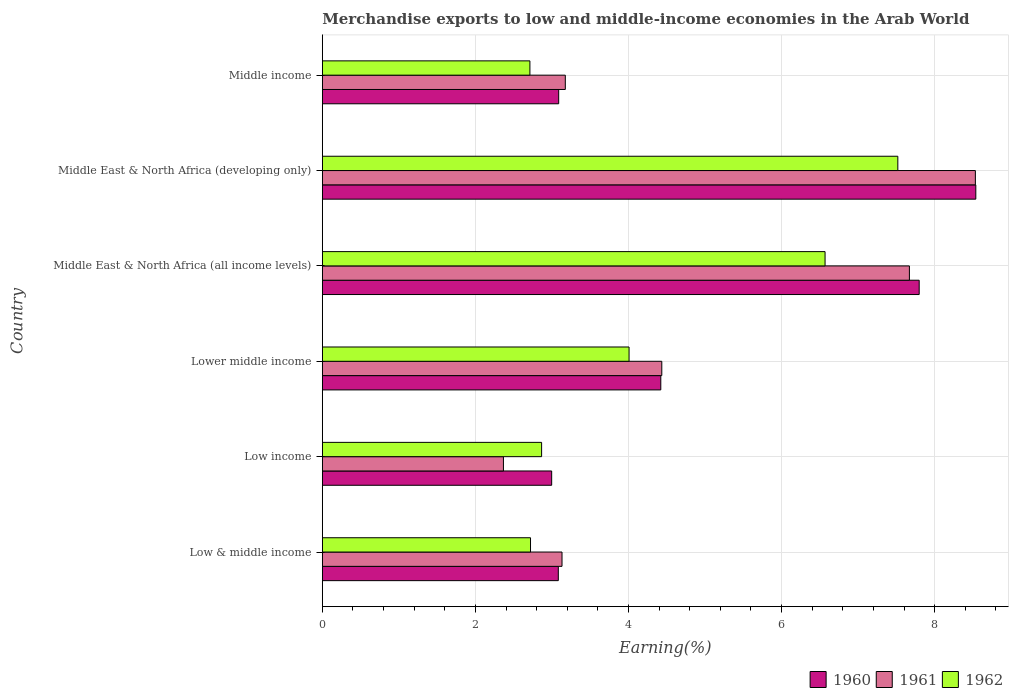How many different coloured bars are there?
Make the answer very short. 3. What is the label of the 2nd group of bars from the top?
Make the answer very short. Middle East & North Africa (developing only). What is the percentage of amount earned from merchandise exports in 1962 in Lower middle income?
Offer a terse response. 4.01. Across all countries, what is the maximum percentage of amount earned from merchandise exports in 1961?
Keep it short and to the point. 8.53. Across all countries, what is the minimum percentage of amount earned from merchandise exports in 1962?
Provide a succinct answer. 2.71. In which country was the percentage of amount earned from merchandise exports in 1961 maximum?
Make the answer very short. Middle East & North Africa (developing only). In which country was the percentage of amount earned from merchandise exports in 1962 minimum?
Provide a succinct answer. Middle income. What is the total percentage of amount earned from merchandise exports in 1960 in the graph?
Your answer should be compact. 29.92. What is the difference between the percentage of amount earned from merchandise exports in 1960 in Lower middle income and that in Middle East & North Africa (developing only)?
Keep it short and to the point. -4.12. What is the difference between the percentage of amount earned from merchandise exports in 1962 in Middle East & North Africa (developing only) and the percentage of amount earned from merchandise exports in 1961 in Middle East & North Africa (all income levels)?
Give a very brief answer. -0.15. What is the average percentage of amount earned from merchandise exports in 1962 per country?
Offer a very short reply. 4.4. What is the difference between the percentage of amount earned from merchandise exports in 1962 and percentage of amount earned from merchandise exports in 1961 in Middle East & North Africa (all income levels)?
Your answer should be compact. -1.1. In how many countries, is the percentage of amount earned from merchandise exports in 1960 greater than 2 %?
Your answer should be very brief. 6. What is the ratio of the percentage of amount earned from merchandise exports in 1962 in Low income to that in Middle East & North Africa (developing only)?
Provide a short and direct response. 0.38. Is the difference between the percentage of amount earned from merchandise exports in 1962 in Low & middle income and Middle East & North Africa (all income levels) greater than the difference between the percentage of amount earned from merchandise exports in 1961 in Low & middle income and Middle East & North Africa (all income levels)?
Keep it short and to the point. Yes. What is the difference between the highest and the second highest percentage of amount earned from merchandise exports in 1960?
Your answer should be compact. 0.74. What is the difference between the highest and the lowest percentage of amount earned from merchandise exports in 1962?
Give a very brief answer. 4.81. Is it the case that in every country, the sum of the percentage of amount earned from merchandise exports in 1960 and percentage of amount earned from merchandise exports in 1962 is greater than the percentage of amount earned from merchandise exports in 1961?
Your response must be concise. Yes. How many bars are there?
Provide a succinct answer. 18. Are the values on the major ticks of X-axis written in scientific E-notation?
Keep it short and to the point. No. Does the graph contain grids?
Keep it short and to the point. Yes. Where does the legend appear in the graph?
Offer a very short reply. Bottom right. How are the legend labels stacked?
Your answer should be very brief. Horizontal. What is the title of the graph?
Provide a succinct answer. Merchandise exports to low and middle-income economies in the Arab World. What is the label or title of the X-axis?
Provide a short and direct response. Earning(%). What is the label or title of the Y-axis?
Give a very brief answer. Country. What is the Earning(%) of 1960 in Low & middle income?
Keep it short and to the point. 3.08. What is the Earning(%) of 1961 in Low & middle income?
Your answer should be compact. 3.13. What is the Earning(%) of 1962 in Low & middle income?
Your answer should be very brief. 2.72. What is the Earning(%) in 1960 in Low income?
Your answer should be compact. 3. What is the Earning(%) in 1961 in Low income?
Your response must be concise. 2.37. What is the Earning(%) of 1962 in Low income?
Ensure brevity in your answer.  2.86. What is the Earning(%) of 1960 in Lower middle income?
Ensure brevity in your answer.  4.42. What is the Earning(%) in 1961 in Lower middle income?
Provide a succinct answer. 4.43. What is the Earning(%) of 1962 in Lower middle income?
Offer a terse response. 4.01. What is the Earning(%) in 1960 in Middle East & North Africa (all income levels)?
Give a very brief answer. 7.8. What is the Earning(%) of 1961 in Middle East & North Africa (all income levels)?
Ensure brevity in your answer.  7.67. What is the Earning(%) in 1962 in Middle East & North Africa (all income levels)?
Your response must be concise. 6.57. What is the Earning(%) in 1960 in Middle East & North Africa (developing only)?
Offer a terse response. 8.54. What is the Earning(%) in 1961 in Middle East & North Africa (developing only)?
Provide a short and direct response. 8.53. What is the Earning(%) in 1962 in Middle East & North Africa (developing only)?
Ensure brevity in your answer.  7.52. What is the Earning(%) of 1960 in Middle income?
Provide a short and direct response. 3.09. What is the Earning(%) in 1961 in Middle income?
Provide a succinct answer. 3.17. What is the Earning(%) in 1962 in Middle income?
Give a very brief answer. 2.71. Across all countries, what is the maximum Earning(%) in 1960?
Provide a short and direct response. 8.54. Across all countries, what is the maximum Earning(%) of 1961?
Ensure brevity in your answer.  8.53. Across all countries, what is the maximum Earning(%) of 1962?
Make the answer very short. 7.52. Across all countries, what is the minimum Earning(%) of 1960?
Make the answer very short. 3. Across all countries, what is the minimum Earning(%) of 1961?
Give a very brief answer. 2.37. Across all countries, what is the minimum Earning(%) of 1962?
Make the answer very short. 2.71. What is the total Earning(%) in 1960 in the graph?
Ensure brevity in your answer.  29.92. What is the total Earning(%) of 1961 in the graph?
Ensure brevity in your answer.  29.31. What is the total Earning(%) of 1962 in the graph?
Give a very brief answer. 26.39. What is the difference between the Earning(%) in 1960 in Low & middle income and that in Low income?
Your answer should be compact. 0.09. What is the difference between the Earning(%) of 1961 in Low & middle income and that in Low income?
Ensure brevity in your answer.  0.77. What is the difference between the Earning(%) in 1962 in Low & middle income and that in Low income?
Keep it short and to the point. -0.14. What is the difference between the Earning(%) of 1960 in Low & middle income and that in Lower middle income?
Your response must be concise. -1.34. What is the difference between the Earning(%) of 1961 in Low & middle income and that in Lower middle income?
Your answer should be compact. -1.3. What is the difference between the Earning(%) of 1962 in Low & middle income and that in Lower middle income?
Provide a succinct answer. -1.29. What is the difference between the Earning(%) in 1960 in Low & middle income and that in Middle East & North Africa (all income levels)?
Provide a succinct answer. -4.71. What is the difference between the Earning(%) in 1961 in Low & middle income and that in Middle East & North Africa (all income levels)?
Ensure brevity in your answer.  -4.54. What is the difference between the Earning(%) of 1962 in Low & middle income and that in Middle East & North Africa (all income levels)?
Ensure brevity in your answer.  -3.85. What is the difference between the Earning(%) in 1960 in Low & middle income and that in Middle East & North Africa (developing only)?
Your answer should be very brief. -5.45. What is the difference between the Earning(%) of 1961 in Low & middle income and that in Middle East & North Africa (developing only)?
Your answer should be compact. -5.4. What is the difference between the Earning(%) of 1962 in Low & middle income and that in Middle East & North Africa (developing only)?
Provide a short and direct response. -4.8. What is the difference between the Earning(%) in 1960 in Low & middle income and that in Middle income?
Offer a very short reply. -0. What is the difference between the Earning(%) of 1961 in Low & middle income and that in Middle income?
Your response must be concise. -0.04. What is the difference between the Earning(%) of 1962 in Low & middle income and that in Middle income?
Make the answer very short. 0.01. What is the difference between the Earning(%) in 1960 in Low income and that in Lower middle income?
Make the answer very short. -1.43. What is the difference between the Earning(%) in 1961 in Low income and that in Lower middle income?
Your answer should be compact. -2.07. What is the difference between the Earning(%) of 1962 in Low income and that in Lower middle income?
Give a very brief answer. -1.14. What is the difference between the Earning(%) of 1960 in Low income and that in Middle East & North Africa (all income levels)?
Offer a very short reply. -4.8. What is the difference between the Earning(%) in 1961 in Low income and that in Middle East & North Africa (all income levels)?
Your answer should be compact. -5.3. What is the difference between the Earning(%) of 1962 in Low income and that in Middle East & North Africa (all income levels)?
Offer a terse response. -3.7. What is the difference between the Earning(%) in 1960 in Low income and that in Middle East & North Africa (developing only)?
Your answer should be compact. -5.54. What is the difference between the Earning(%) in 1961 in Low income and that in Middle East & North Africa (developing only)?
Offer a very short reply. -6.17. What is the difference between the Earning(%) of 1962 in Low income and that in Middle East & North Africa (developing only)?
Keep it short and to the point. -4.65. What is the difference between the Earning(%) of 1960 in Low income and that in Middle income?
Your answer should be compact. -0.09. What is the difference between the Earning(%) in 1961 in Low income and that in Middle income?
Your response must be concise. -0.81. What is the difference between the Earning(%) of 1962 in Low income and that in Middle income?
Make the answer very short. 0.15. What is the difference between the Earning(%) of 1960 in Lower middle income and that in Middle East & North Africa (all income levels)?
Your answer should be compact. -3.38. What is the difference between the Earning(%) in 1961 in Lower middle income and that in Middle East & North Africa (all income levels)?
Give a very brief answer. -3.23. What is the difference between the Earning(%) of 1962 in Lower middle income and that in Middle East & North Africa (all income levels)?
Provide a succinct answer. -2.56. What is the difference between the Earning(%) of 1960 in Lower middle income and that in Middle East & North Africa (developing only)?
Offer a very short reply. -4.12. What is the difference between the Earning(%) of 1961 in Lower middle income and that in Middle East & North Africa (developing only)?
Provide a short and direct response. -4.1. What is the difference between the Earning(%) in 1962 in Lower middle income and that in Middle East & North Africa (developing only)?
Give a very brief answer. -3.51. What is the difference between the Earning(%) of 1960 in Lower middle income and that in Middle income?
Provide a short and direct response. 1.33. What is the difference between the Earning(%) of 1961 in Lower middle income and that in Middle income?
Ensure brevity in your answer.  1.26. What is the difference between the Earning(%) in 1962 in Lower middle income and that in Middle income?
Your answer should be very brief. 1.3. What is the difference between the Earning(%) of 1960 in Middle East & North Africa (all income levels) and that in Middle East & North Africa (developing only)?
Offer a terse response. -0.74. What is the difference between the Earning(%) in 1961 in Middle East & North Africa (all income levels) and that in Middle East & North Africa (developing only)?
Offer a very short reply. -0.86. What is the difference between the Earning(%) of 1962 in Middle East & North Africa (all income levels) and that in Middle East & North Africa (developing only)?
Provide a short and direct response. -0.95. What is the difference between the Earning(%) of 1960 in Middle East & North Africa (all income levels) and that in Middle income?
Provide a succinct answer. 4.71. What is the difference between the Earning(%) in 1961 in Middle East & North Africa (all income levels) and that in Middle income?
Offer a very short reply. 4.5. What is the difference between the Earning(%) in 1962 in Middle East & North Africa (all income levels) and that in Middle income?
Provide a succinct answer. 3.86. What is the difference between the Earning(%) in 1960 in Middle East & North Africa (developing only) and that in Middle income?
Your answer should be compact. 5.45. What is the difference between the Earning(%) in 1961 in Middle East & North Africa (developing only) and that in Middle income?
Offer a terse response. 5.36. What is the difference between the Earning(%) in 1962 in Middle East & North Africa (developing only) and that in Middle income?
Provide a succinct answer. 4.81. What is the difference between the Earning(%) of 1960 in Low & middle income and the Earning(%) of 1961 in Low income?
Make the answer very short. 0.72. What is the difference between the Earning(%) in 1960 in Low & middle income and the Earning(%) in 1962 in Low income?
Offer a terse response. 0.22. What is the difference between the Earning(%) of 1961 in Low & middle income and the Earning(%) of 1962 in Low income?
Provide a short and direct response. 0.27. What is the difference between the Earning(%) of 1960 in Low & middle income and the Earning(%) of 1961 in Lower middle income?
Offer a terse response. -1.35. What is the difference between the Earning(%) of 1960 in Low & middle income and the Earning(%) of 1962 in Lower middle income?
Provide a short and direct response. -0.92. What is the difference between the Earning(%) of 1961 in Low & middle income and the Earning(%) of 1962 in Lower middle income?
Your response must be concise. -0.88. What is the difference between the Earning(%) of 1960 in Low & middle income and the Earning(%) of 1961 in Middle East & North Africa (all income levels)?
Give a very brief answer. -4.59. What is the difference between the Earning(%) in 1960 in Low & middle income and the Earning(%) in 1962 in Middle East & North Africa (all income levels)?
Your response must be concise. -3.48. What is the difference between the Earning(%) of 1961 in Low & middle income and the Earning(%) of 1962 in Middle East & North Africa (all income levels)?
Make the answer very short. -3.44. What is the difference between the Earning(%) in 1960 in Low & middle income and the Earning(%) in 1961 in Middle East & North Africa (developing only)?
Offer a terse response. -5.45. What is the difference between the Earning(%) in 1960 in Low & middle income and the Earning(%) in 1962 in Middle East & North Africa (developing only)?
Provide a short and direct response. -4.44. What is the difference between the Earning(%) of 1961 in Low & middle income and the Earning(%) of 1962 in Middle East & North Africa (developing only)?
Offer a terse response. -4.39. What is the difference between the Earning(%) of 1960 in Low & middle income and the Earning(%) of 1961 in Middle income?
Make the answer very short. -0.09. What is the difference between the Earning(%) in 1960 in Low & middle income and the Earning(%) in 1962 in Middle income?
Give a very brief answer. 0.37. What is the difference between the Earning(%) in 1961 in Low & middle income and the Earning(%) in 1962 in Middle income?
Ensure brevity in your answer.  0.42. What is the difference between the Earning(%) of 1960 in Low income and the Earning(%) of 1961 in Lower middle income?
Ensure brevity in your answer.  -1.44. What is the difference between the Earning(%) in 1960 in Low income and the Earning(%) in 1962 in Lower middle income?
Your answer should be very brief. -1.01. What is the difference between the Earning(%) in 1961 in Low income and the Earning(%) in 1962 in Lower middle income?
Provide a succinct answer. -1.64. What is the difference between the Earning(%) in 1960 in Low income and the Earning(%) in 1961 in Middle East & North Africa (all income levels)?
Provide a short and direct response. -4.67. What is the difference between the Earning(%) of 1960 in Low income and the Earning(%) of 1962 in Middle East & North Africa (all income levels)?
Offer a very short reply. -3.57. What is the difference between the Earning(%) in 1961 in Low income and the Earning(%) in 1962 in Middle East & North Africa (all income levels)?
Offer a very short reply. -4.2. What is the difference between the Earning(%) in 1960 in Low income and the Earning(%) in 1961 in Middle East & North Africa (developing only)?
Your response must be concise. -5.54. What is the difference between the Earning(%) of 1960 in Low income and the Earning(%) of 1962 in Middle East & North Africa (developing only)?
Offer a very short reply. -4.52. What is the difference between the Earning(%) of 1961 in Low income and the Earning(%) of 1962 in Middle East & North Africa (developing only)?
Give a very brief answer. -5.15. What is the difference between the Earning(%) in 1960 in Low income and the Earning(%) in 1961 in Middle income?
Your answer should be compact. -0.18. What is the difference between the Earning(%) of 1960 in Low income and the Earning(%) of 1962 in Middle income?
Provide a succinct answer. 0.28. What is the difference between the Earning(%) in 1961 in Low income and the Earning(%) in 1962 in Middle income?
Your answer should be very brief. -0.35. What is the difference between the Earning(%) in 1960 in Lower middle income and the Earning(%) in 1961 in Middle East & North Africa (all income levels)?
Provide a short and direct response. -3.25. What is the difference between the Earning(%) of 1960 in Lower middle income and the Earning(%) of 1962 in Middle East & North Africa (all income levels)?
Provide a succinct answer. -2.15. What is the difference between the Earning(%) in 1961 in Lower middle income and the Earning(%) in 1962 in Middle East & North Africa (all income levels)?
Provide a short and direct response. -2.13. What is the difference between the Earning(%) of 1960 in Lower middle income and the Earning(%) of 1961 in Middle East & North Africa (developing only)?
Offer a very short reply. -4.11. What is the difference between the Earning(%) of 1960 in Lower middle income and the Earning(%) of 1962 in Middle East & North Africa (developing only)?
Provide a short and direct response. -3.1. What is the difference between the Earning(%) in 1961 in Lower middle income and the Earning(%) in 1962 in Middle East & North Africa (developing only)?
Offer a terse response. -3.08. What is the difference between the Earning(%) of 1960 in Lower middle income and the Earning(%) of 1961 in Middle income?
Provide a succinct answer. 1.25. What is the difference between the Earning(%) in 1960 in Lower middle income and the Earning(%) in 1962 in Middle income?
Ensure brevity in your answer.  1.71. What is the difference between the Earning(%) of 1961 in Lower middle income and the Earning(%) of 1962 in Middle income?
Provide a succinct answer. 1.72. What is the difference between the Earning(%) of 1960 in Middle East & North Africa (all income levels) and the Earning(%) of 1961 in Middle East & North Africa (developing only)?
Provide a succinct answer. -0.73. What is the difference between the Earning(%) of 1960 in Middle East & North Africa (all income levels) and the Earning(%) of 1962 in Middle East & North Africa (developing only)?
Your response must be concise. 0.28. What is the difference between the Earning(%) in 1961 in Middle East & North Africa (all income levels) and the Earning(%) in 1962 in Middle East & North Africa (developing only)?
Offer a very short reply. 0.15. What is the difference between the Earning(%) in 1960 in Middle East & North Africa (all income levels) and the Earning(%) in 1961 in Middle income?
Your answer should be very brief. 4.62. What is the difference between the Earning(%) in 1960 in Middle East & North Africa (all income levels) and the Earning(%) in 1962 in Middle income?
Keep it short and to the point. 5.09. What is the difference between the Earning(%) of 1961 in Middle East & North Africa (all income levels) and the Earning(%) of 1962 in Middle income?
Your answer should be very brief. 4.96. What is the difference between the Earning(%) of 1960 in Middle East & North Africa (developing only) and the Earning(%) of 1961 in Middle income?
Provide a succinct answer. 5.36. What is the difference between the Earning(%) of 1960 in Middle East & North Africa (developing only) and the Earning(%) of 1962 in Middle income?
Offer a terse response. 5.83. What is the difference between the Earning(%) of 1961 in Middle East & North Africa (developing only) and the Earning(%) of 1962 in Middle income?
Offer a very short reply. 5.82. What is the average Earning(%) of 1960 per country?
Your answer should be very brief. 4.99. What is the average Earning(%) in 1961 per country?
Your answer should be compact. 4.88. What is the average Earning(%) in 1962 per country?
Make the answer very short. 4.4. What is the difference between the Earning(%) in 1960 and Earning(%) in 1961 in Low & middle income?
Offer a terse response. -0.05. What is the difference between the Earning(%) in 1960 and Earning(%) in 1962 in Low & middle income?
Provide a short and direct response. 0.36. What is the difference between the Earning(%) in 1961 and Earning(%) in 1962 in Low & middle income?
Offer a very short reply. 0.41. What is the difference between the Earning(%) of 1960 and Earning(%) of 1961 in Low income?
Keep it short and to the point. 0.63. What is the difference between the Earning(%) of 1960 and Earning(%) of 1962 in Low income?
Make the answer very short. 0.13. What is the difference between the Earning(%) of 1961 and Earning(%) of 1962 in Low income?
Provide a succinct answer. -0.5. What is the difference between the Earning(%) in 1960 and Earning(%) in 1961 in Lower middle income?
Your answer should be very brief. -0.01. What is the difference between the Earning(%) of 1960 and Earning(%) of 1962 in Lower middle income?
Your answer should be compact. 0.41. What is the difference between the Earning(%) of 1961 and Earning(%) of 1962 in Lower middle income?
Make the answer very short. 0.43. What is the difference between the Earning(%) of 1960 and Earning(%) of 1961 in Middle East & North Africa (all income levels)?
Offer a very short reply. 0.13. What is the difference between the Earning(%) in 1960 and Earning(%) in 1962 in Middle East & North Africa (all income levels)?
Provide a short and direct response. 1.23. What is the difference between the Earning(%) in 1961 and Earning(%) in 1962 in Middle East & North Africa (all income levels)?
Provide a short and direct response. 1.1. What is the difference between the Earning(%) of 1960 and Earning(%) of 1961 in Middle East & North Africa (developing only)?
Offer a terse response. 0.01. What is the difference between the Earning(%) of 1960 and Earning(%) of 1962 in Middle East & North Africa (developing only)?
Ensure brevity in your answer.  1.02. What is the difference between the Earning(%) of 1961 and Earning(%) of 1962 in Middle East & North Africa (developing only)?
Make the answer very short. 1.01. What is the difference between the Earning(%) in 1960 and Earning(%) in 1961 in Middle income?
Your response must be concise. -0.09. What is the difference between the Earning(%) of 1960 and Earning(%) of 1962 in Middle income?
Provide a succinct answer. 0.38. What is the difference between the Earning(%) of 1961 and Earning(%) of 1962 in Middle income?
Give a very brief answer. 0.46. What is the ratio of the Earning(%) in 1960 in Low & middle income to that in Low income?
Give a very brief answer. 1.03. What is the ratio of the Earning(%) in 1961 in Low & middle income to that in Low income?
Ensure brevity in your answer.  1.32. What is the ratio of the Earning(%) of 1962 in Low & middle income to that in Low income?
Your answer should be very brief. 0.95. What is the ratio of the Earning(%) in 1960 in Low & middle income to that in Lower middle income?
Offer a very short reply. 0.7. What is the ratio of the Earning(%) of 1961 in Low & middle income to that in Lower middle income?
Your answer should be very brief. 0.71. What is the ratio of the Earning(%) of 1962 in Low & middle income to that in Lower middle income?
Your response must be concise. 0.68. What is the ratio of the Earning(%) of 1960 in Low & middle income to that in Middle East & North Africa (all income levels)?
Offer a very short reply. 0.4. What is the ratio of the Earning(%) in 1961 in Low & middle income to that in Middle East & North Africa (all income levels)?
Provide a succinct answer. 0.41. What is the ratio of the Earning(%) of 1962 in Low & middle income to that in Middle East & North Africa (all income levels)?
Give a very brief answer. 0.41. What is the ratio of the Earning(%) in 1960 in Low & middle income to that in Middle East & North Africa (developing only)?
Keep it short and to the point. 0.36. What is the ratio of the Earning(%) in 1961 in Low & middle income to that in Middle East & North Africa (developing only)?
Give a very brief answer. 0.37. What is the ratio of the Earning(%) of 1962 in Low & middle income to that in Middle East & North Africa (developing only)?
Offer a very short reply. 0.36. What is the ratio of the Earning(%) in 1960 in Low & middle income to that in Middle income?
Your answer should be very brief. 1. What is the ratio of the Earning(%) of 1961 in Low & middle income to that in Middle income?
Provide a short and direct response. 0.99. What is the ratio of the Earning(%) of 1962 in Low & middle income to that in Middle income?
Your answer should be compact. 1. What is the ratio of the Earning(%) in 1960 in Low income to that in Lower middle income?
Your response must be concise. 0.68. What is the ratio of the Earning(%) of 1961 in Low income to that in Lower middle income?
Ensure brevity in your answer.  0.53. What is the ratio of the Earning(%) in 1962 in Low income to that in Lower middle income?
Offer a terse response. 0.71. What is the ratio of the Earning(%) in 1960 in Low income to that in Middle East & North Africa (all income levels)?
Your response must be concise. 0.38. What is the ratio of the Earning(%) in 1961 in Low income to that in Middle East & North Africa (all income levels)?
Make the answer very short. 0.31. What is the ratio of the Earning(%) in 1962 in Low income to that in Middle East & North Africa (all income levels)?
Make the answer very short. 0.44. What is the ratio of the Earning(%) of 1960 in Low income to that in Middle East & North Africa (developing only)?
Make the answer very short. 0.35. What is the ratio of the Earning(%) in 1961 in Low income to that in Middle East & North Africa (developing only)?
Provide a succinct answer. 0.28. What is the ratio of the Earning(%) in 1962 in Low income to that in Middle East & North Africa (developing only)?
Provide a succinct answer. 0.38. What is the ratio of the Earning(%) in 1960 in Low income to that in Middle income?
Offer a very short reply. 0.97. What is the ratio of the Earning(%) of 1961 in Low income to that in Middle income?
Give a very brief answer. 0.75. What is the ratio of the Earning(%) in 1962 in Low income to that in Middle income?
Provide a short and direct response. 1.06. What is the ratio of the Earning(%) of 1960 in Lower middle income to that in Middle East & North Africa (all income levels)?
Provide a short and direct response. 0.57. What is the ratio of the Earning(%) in 1961 in Lower middle income to that in Middle East & North Africa (all income levels)?
Offer a very short reply. 0.58. What is the ratio of the Earning(%) in 1962 in Lower middle income to that in Middle East & North Africa (all income levels)?
Keep it short and to the point. 0.61. What is the ratio of the Earning(%) in 1960 in Lower middle income to that in Middle East & North Africa (developing only)?
Your answer should be very brief. 0.52. What is the ratio of the Earning(%) of 1961 in Lower middle income to that in Middle East & North Africa (developing only)?
Make the answer very short. 0.52. What is the ratio of the Earning(%) of 1962 in Lower middle income to that in Middle East & North Africa (developing only)?
Your response must be concise. 0.53. What is the ratio of the Earning(%) in 1960 in Lower middle income to that in Middle income?
Offer a terse response. 1.43. What is the ratio of the Earning(%) in 1961 in Lower middle income to that in Middle income?
Provide a short and direct response. 1.4. What is the ratio of the Earning(%) of 1962 in Lower middle income to that in Middle income?
Give a very brief answer. 1.48. What is the ratio of the Earning(%) of 1960 in Middle East & North Africa (all income levels) to that in Middle East & North Africa (developing only)?
Provide a short and direct response. 0.91. What is the ratio of the Earning(%) in 1961 in Middle East & North Africa (all income levels) to that in Middle East & North Africa (developing only)?
Your response must be concise. 0.9. What is the ratio of the Earning(%) in 1962 in Middle East & North Africa (all income levels) to that in Middle East & North Africa (developing only)?
Provide a succinct answer. 0.87. What is the ratio of the Earning(%) in 1960 in Middle East & North Africa (all income levels) to that in Middle income?
Your answer should be compact. 2.53. What is the ratio of the Earning(%) of 1961 in Middle East & North Africa (all income levels) to that in Middle income?
Keep it short and to the point. 2.42. What is the ratio of the Earning(%) in 1962 in Middle East & North Africa (all income levels) to that in Middle income?
Offer a terse response. 2.42. What is the ratio of the Earning(%) in 1960 in Middle East & North Africa (developing only) to that in Middle income?
Keep it short and to the point. 2.76. What is the ratio of the Earning(%) of 1961 in Middle East & North Africa (developing only) to that in Middle income?
Make the answer very short. 2.69. What is the ratio of the Earning(%) in 1962 in Middle East & North Africa (developing only) to that in Middle income?
Your answer should be compact. 2.77. What is the difference between the highest and the second highest Earning(%) of 1960?
Your response must be concise. 0.74. What is the difference between the highest and the second highest Earning(%) in 1961?
Offer a very short reply. 0.86. What is the difference between the highest and the second highest Earning(%) in 1962?
Your answer should be very brief. 0.95. What is the difference between the highest and the lowest Earning(%) of 1960?
Offer a very short reply. 5.54. What is the difference between the highest and the lowest Earning(%) in 1961?
Keep it short and to the point. 6.17. What is the difference between the highest and the lowest Earning(%) of 1962?
Ensure brevity in your answer.  4.81. 